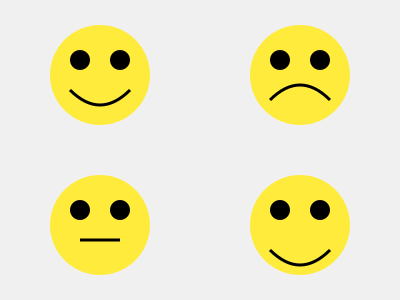Which emotion is not represented in the facial expressions shown in the image? To answer this question, we need to analyze the facial expressions depicted in the image and identify the emotions they represent. Let's examine each face:

1. Top-left face: The eyes are open, and there's an upward curve in the mouth. This typically represents happiness or joy.

2. Top-right face: The eyes are open, but the mouth has a downward curve. This usually indicates sadness or disappointment.

3. Bottom-left face: The eyes are open, and the mouth is a straight line. This often represents a neutral expression or sometimes seriousness.

4. Bottom-right face: The eyes are open, and there's a pronounced upward curve in the mouth. This typically represents extreme happiness or excitement.

The emotions represented in the image are:
- Happiness/Joy
- Sadness/Disappointment
- Neutral/Serious
- Extreme happiness/Excitement

A common emotion that is not represented in these facial expressions is anger or frustration, which would typically be shown with furrowed brows and a tightened or downturned mouth.
Answer: Anger 